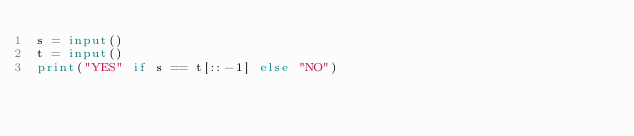Convert code to text. <code><loc_0><loc_0><loc_500><loc_500><_Python_>s = input()
t = input()
print("YES" if s == t[::-1] else "NO")





</code> 